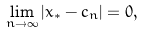<formula> <loc_0><loc_0><loc_500><loc_500>\lim _ { n \rightarrow \infty } \left | x _ { * } - c _ { n } \right | = 0 ,</formula> 